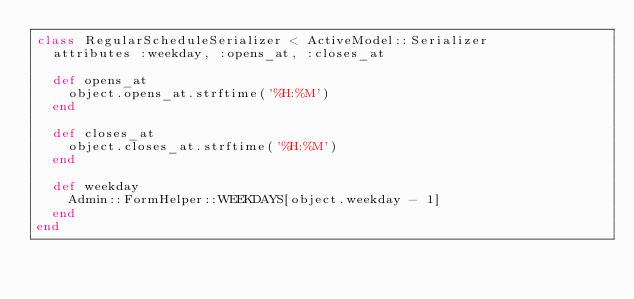<code> <loc_0><loc_0><loc_500><loc_500><_Ruby_>class RegularScheduleSerializer < ActiveModel::Serializer
  attributes :weekday, :opens_at, :closes_at

  def opens_at
    object.opens_at.strftime('%H:%M')
  end

  def closes_at
    object.closes_at.strftime('%H:%M')
  end

  def weekday
    Admin::FormHelper::WEEKDAYS[object.weekday - 1]
  end
end
</code> 